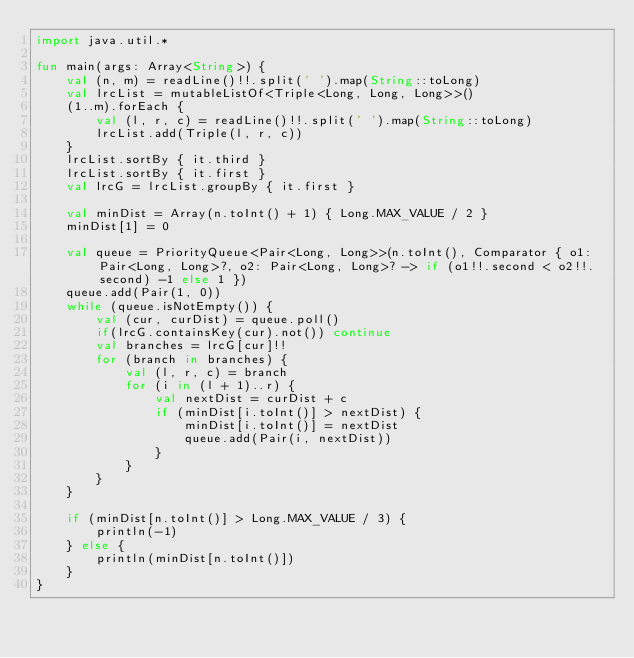Convert code to text. <code><loc_0><loc_0><loc_500><loc_500><_Kotlin_>import java.util.*

fun main(args: Array<String>) {
    val (n, m) = readLine()!!.split(' ').map(String::toLong)
    val lrcList = mutableListOf<Triple<Long, Long, Long>>()
    (1..m).forEach {
        val (l, r, c) = readLine()!!.split(' ').map(String::toLong)
        lrcList.add(Triple(l, r, c))
    }
    lrcList.sortBy { it.third }
    lrcList.sortBy { it.first }
    val lrcG = lrcList.groupBy { it.first }

    val minDist = Array(n.toInt() + 1) { Long.MAX_VALUE / 2 }
    minDist[1] = 0

    val queue = PriorityQueue<Pair<Long, Long>>(n.toInt(), Comparator { o1: Pair<Long, Long>?, o2: Pair<Long, Long>? -> if (o1!!.second < o2!!.second) -1 else 1 })
    queue.add(Pair(1, 0))
    while (queue.isNotEmpty()) {
        val (cur, curDist) = queue.poll()
        if(lrcG.containsKey(cur).not()) continue
        val branches = lrcG[cur]!!
        for (branch in branches) {
            val (l, r, c) = branch
            for (i in (l + 1)..r) {
                val nextDist = curDist + c
                if (minDist[i.toInt()] > nextDist) {
                    minDist[i.toInt()] = nextDist
                    queue.add(Pair(i, nextDist))
                }
            }
        }
    }

    if (minDist[n.toInt()] > Long.MAX_VALUE / 3) {
        println(-1)
    } else {
        println(minDist[n.toInt()])
    }
}</code> 